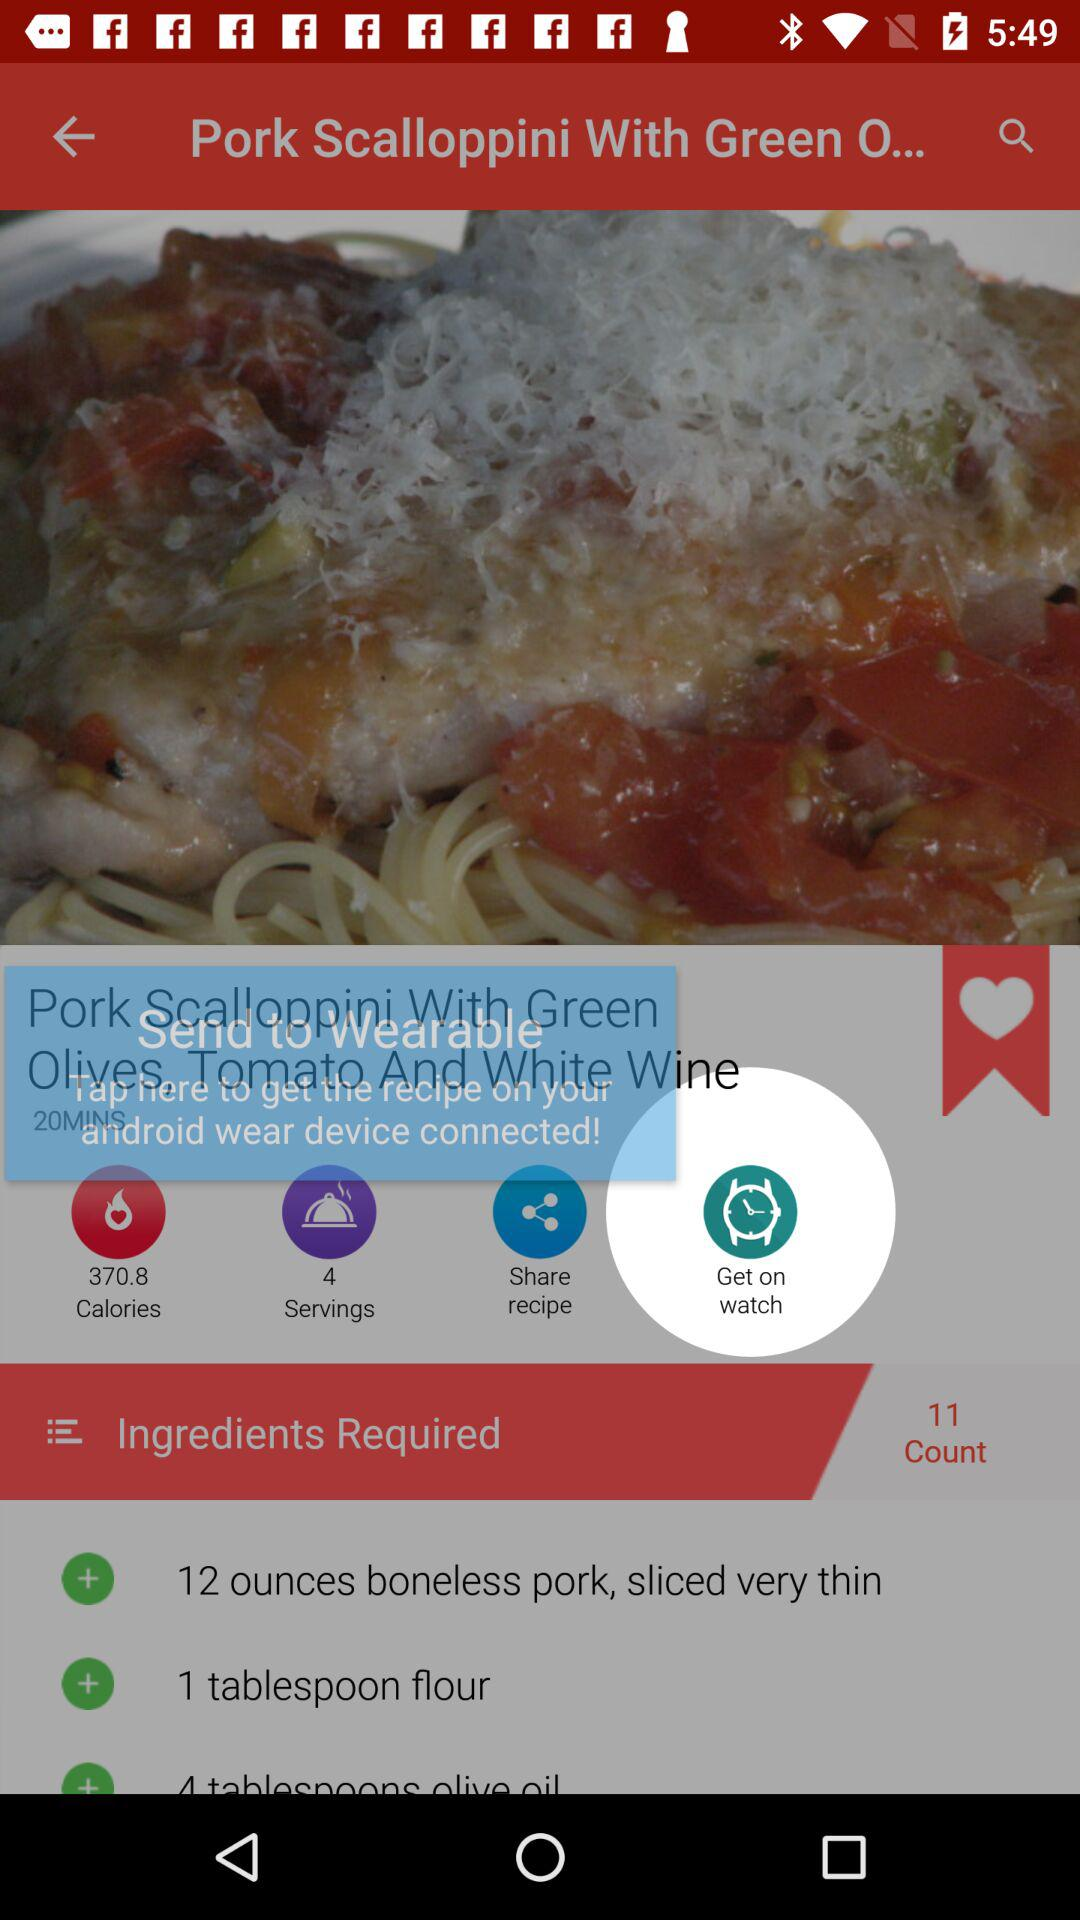How many counts are there? There are 11 counts. 